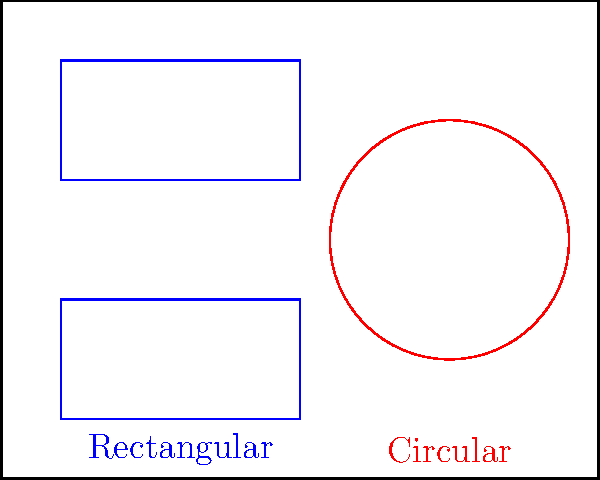As a business owner looking to optimize your office space for Agile teams, you're considering two seating arrangements: rectangular and circular. The rectangular arrangement can accommodate 20 people in two 4x5 meter areas, while the circular arrangement fits 16 people in a circle with a 4-meter diameter. If your office is 10x8 meters, what is the difference in space efficiency (people per square meter) between the two arrangements? Let's approach this step-by-step:

1. Calculate the area of the entire office:
   Office area = $10 \text{ m} \times 8 \text{ m} = 80 \text{ m}^2$

2. Calculate the area used by the rectangular arrangement:
   Rectangular area = $2 \times (4 \text{ m} \times 5 \text{ m}) = 40 \text{ m}^2$

3. Calculate the area used by the circular arrangement:
   Circular area = $\pi r^2 = \pi \times (2 \text{ m})^2 = 12.57 \text{ m}^2$

4. Calculate the efficiency of the rectangular arrangement:
   Rectangular efficiency = $\frac{20 \text{ people}}{40 \text{ m}^2} = 0.5 \text{ people/m}^2$

5. Calculate the efficiency of the circular arrangement:
   Circular efficiency = $\frac{16 \text{ people}}{12.57 \text{ m}^2} = 1.27 \text{ people/m}^2$

6. Calculate the difference in efficiency:
   Difference = $1.27 \text{ people/m}^2 - 0.5 \text{ people/m}^2 = 0.77 \text{ people/m}^2$
Answer: 0.77 people/m² 